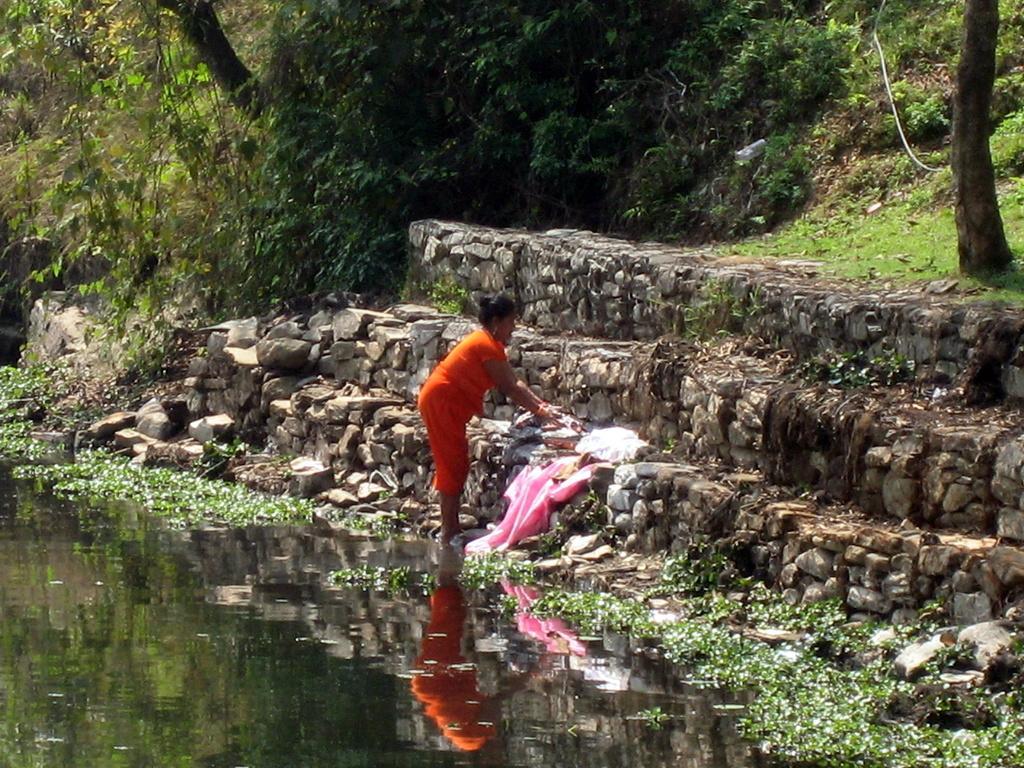Can you describe this image briefly? In the foreground of the picture there are plants, water and staircase. In the center of the picture there is a woman washing clothes. At the top there are trees, plants and grass. 